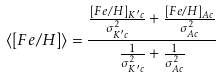<formula> <loc_0><loc_0><loc_500><loc_500>\langle [ F e / H ] \rangle = \frac { \frac { [ F e / H ] _ { K ^ { \prime } c } } { \sigma ^ { 2 } _ { K ^ { \prime } c } } + \frac { [ F e / H ] _ { A c } } { \sigma ^ { 2 } _ { A c } } } { \frac { 1 } { \sigma ^ { 2 } _ { K ^ { \prime } c } } + \frac { 1 } { \sigma ^ { 2 } _ { A c } } }</formula> 